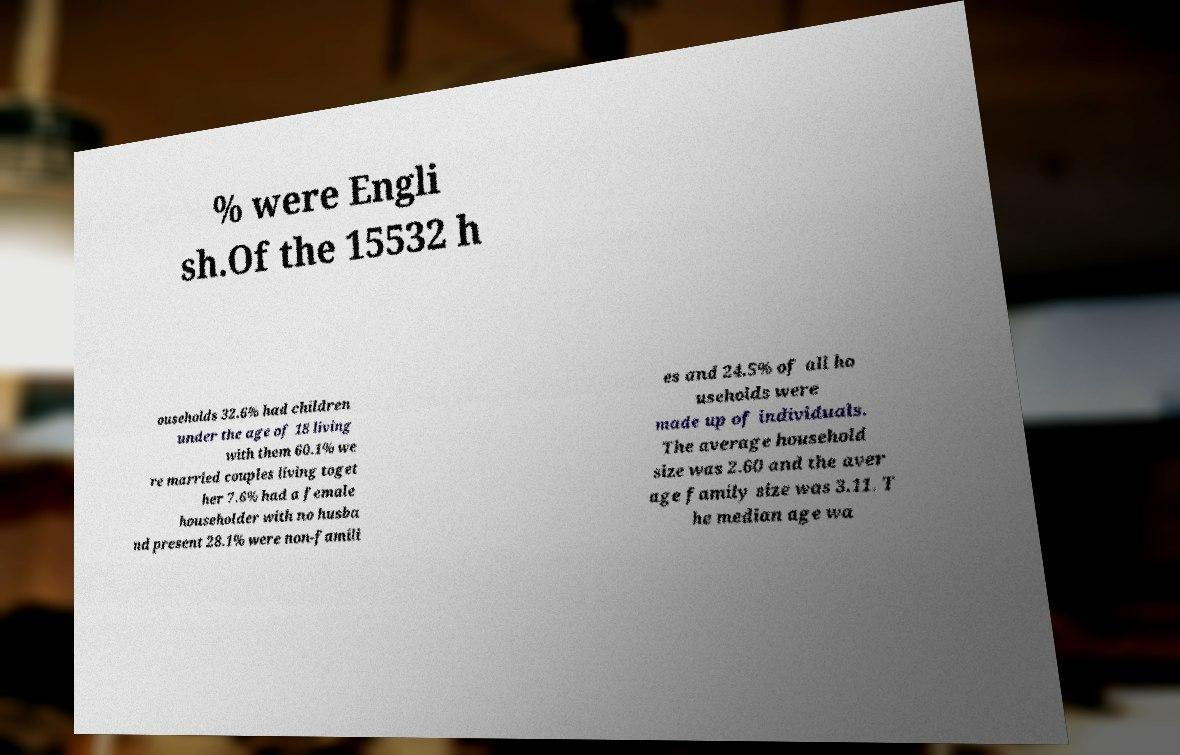I need the written content from this picture converted into text. Can you do that? % were Engli sh.Of the 15532 h ouseholds 32.6% had children under the age of 18 living with them 60.1% we re married couples living toget her 7.6% had a female householder with no husba nd present 28.1% were non-famili es and 24.5% of all ho useholds were made up of individuals. The average household size was 2.60 and the aver age family size was 3.11. T he median age wa 